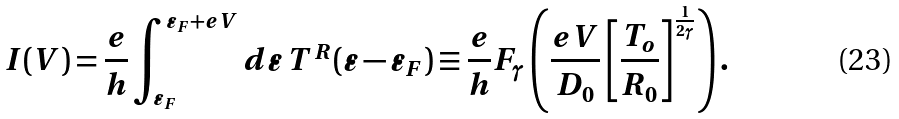<formula> <loc_0><loc_0><loc_500><loc_500>I ( V ) = \frac { e } { h } \int _ { \varepsilon _ { F } } ^ { \varepsilon _ { F } + e V } d \varepsilon \, T ^ { R } ( \varepsilon - \varepsilon _ { F } ) \equiv \frac { e } { h } F _ { \gamma } \left ( \frac { e V } { D _ { 0 } } \left [ \frac { T _ { o } } { R _ { 0 } } \right ] ^ { \frac { 1 } { 2 \gamma } } \right ) .</formula> 